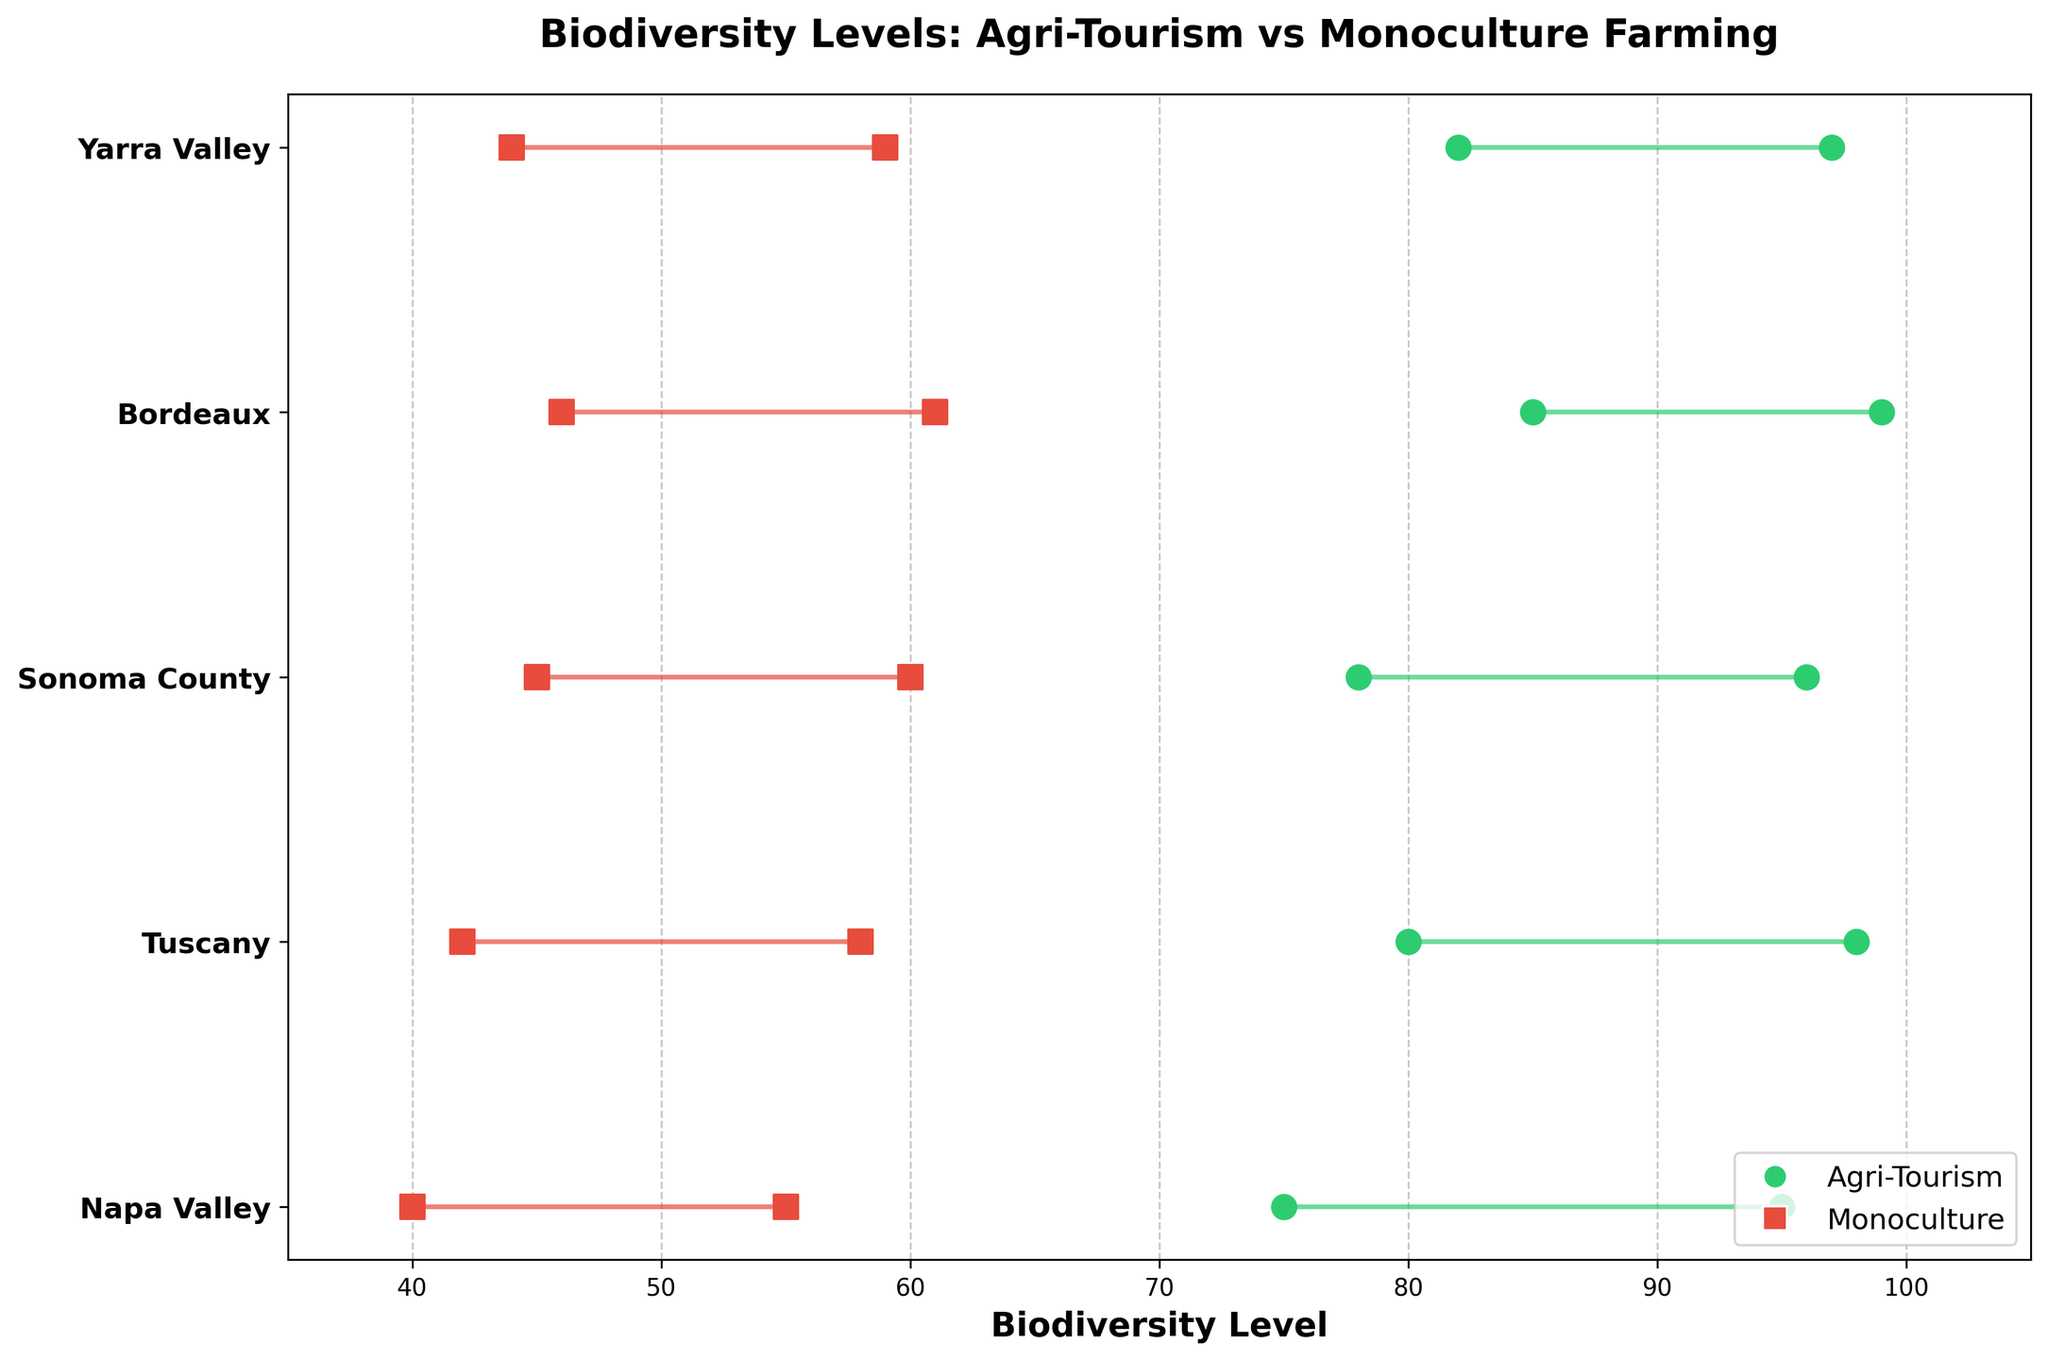What is the title of the plot? The title of the plot is located at the top of the figure in a large, bold font.
Answer: Biodiversity Levels: Agri-Tourism vs Monoculture Farming What is the range of biodiversity levels for Agri-Tourism in Napa Valley? The range is the difference between the highest and lowest biodiversity levels for Agri-Tourism in Napa Valley. The plot shows this range as a line starting from "75" to "95".
Answer: 75 to 95 Which region has the highest maximum biodiversity level in Agri-Tourism? To find the highest maximum biodiversity level, identify the highest point among all regions practicing Agri-Tourism in the plot. Bordeaux's Agri-Tourism has the highest point at "99".
Answer: Bordeaux By how much does the minimum biodiversity level in Monoculture for Bordeaux exceed that for Napa Valley? First, identify the minimum biodiversity levels in Monoculture for both regions: Bordeaux (46) and Napa Valley (40). Subtract Napa Valley's level from Bordeaux's level (46 - 40).
Answer: 6 What is the average maximum biodiversity level in Agri-Tourism across all regions? First identify the maximums for all regions practicing Agri-Tourism: Napa Valley (95), Tuscany (98), Sonoma County (96), Bordeaux (99), and Yarra Valley (97). Sum these values and divide by the number of values (5). (95 + 98 + 96 + 99 + 97) / 5 = 97
Answer: 97 Which type of farming shows a broader range of biodiversity levels in Yarra Valley? Compare the ranges for each type: Agri-Tourism (82 to 97, range is 15) and Monoculture (44 to 59, range is 15). Yarra Valley has equal ranges for both types based on the plot.
Answer: Equal What type of farming practice shows lower variability in biodiversity levels in Sonoma County? Variability is indicated by the length of the range bars. The range for Agri-Tourism is from 78 to 96 (range is 18), while for Monoculture it is from 45 to 60 (range is 15). Monoculture has a smaller range, indicating lower variability.
Answer: Monoculture Which region has the widest range of biodiversity levels for Monoculture farming? To find the widest range, compare the distances between the lowest and highest levels for Monoculture in each region. Bordeaux's range is widest, from 46 to 61 (range is 15).
Answer: Bordeaux Does any region show overlapping ranges for Agri-Tourism and Monoculture farming? Overlapping ranges occur if any part of the bar for Agri-Tourism overlaps with the bar for Monoculture within the same region. No regions have overlapping ranges as per the plot.
Answer: No 